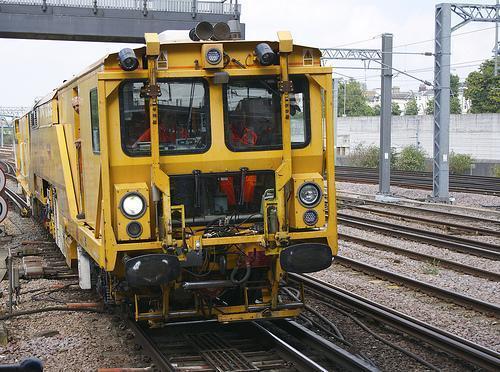How many trains are there?
Give a very brief answer. 1. 